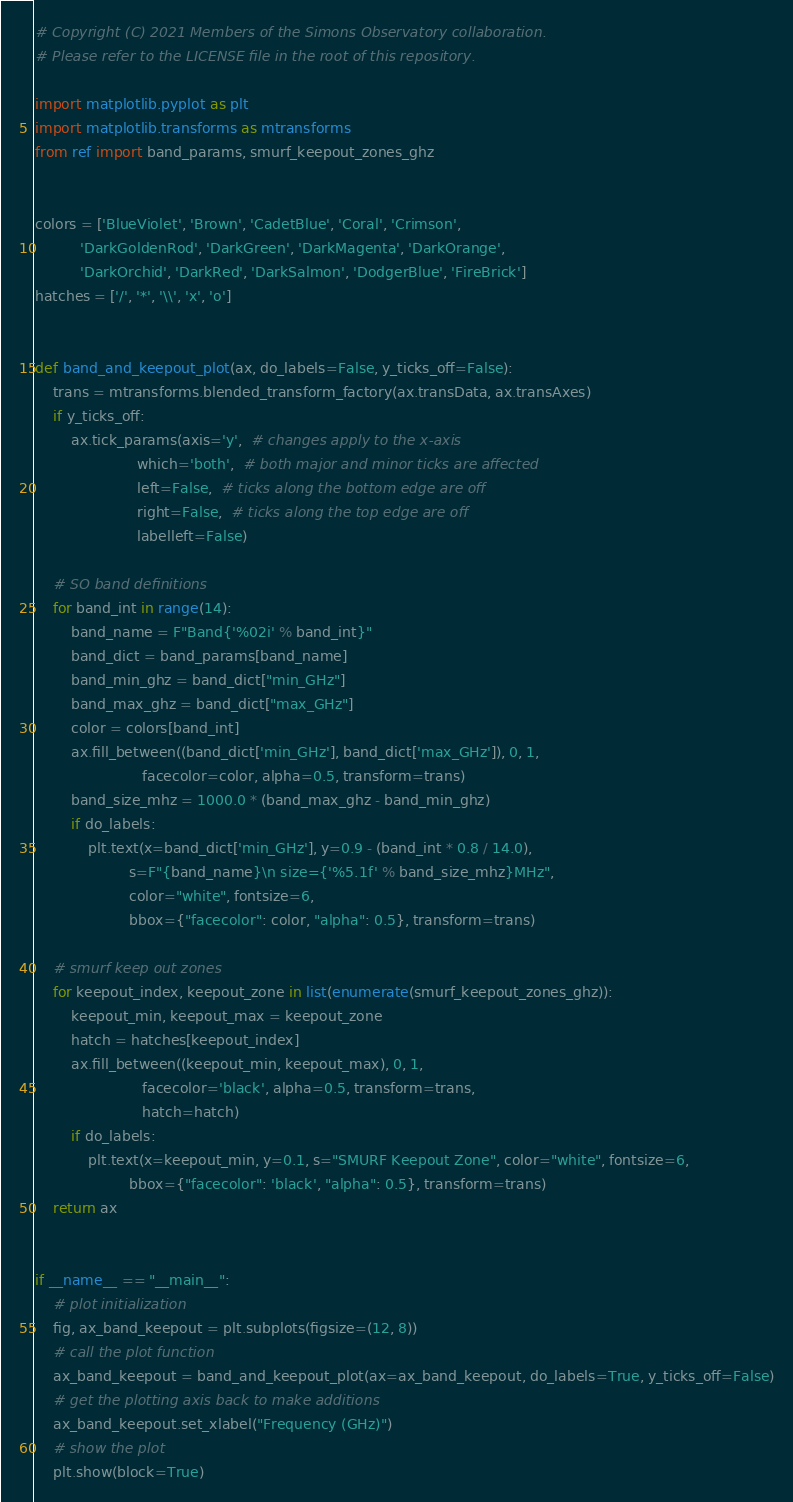<code> <loc_0><loc_0><loc_500><loc_500><_Python_># Copyright (C) 2021 Members of the Simons Observatory collaboration.
# Please refer to the LICENSE file in the root of this repository.

import matplotlib.pyplot as plt
import matplotlib.transforms as mtransforms
from ref import band_params, smurf_keepout_zones_ghz


colors = ['BlueViolet', 'Brown', 'CadetBlue', 'Coral', 'Crimson',
          'DarkGoldenRod', 'DarkGreen', 'DarkMagenta', 'DarkOrange',
          'DarkOrchid', 'DarkRed', 'DarkSalmon', 'DodgerBlue', 'FireBrick']
hatches = ['/', '*', '\\', 'x', 'o']


def band_and_keepout_plot(ax, do_labels=False, y_ticks_off=False):
    trans = mtransforms.blended_transform_factory(ax.transData, ax.transAxes)
    if y_ticks_off:
        ax.tick_params(axis='y',  # changes apply to the x-axis
                       which='both',  # both major and minor ticks are affected
                       left=False,  # ticks along the bottom edge are off
                       right=False,  # ticks along the top edge are off
                       labelleft=False)

    # SO band definitions
    for band_int in range(14):
        band_name = F"Band{'%02i' % band_int}"
        band_dict = band_params[band_name]
        band_min_ghz = band_dict["min_GHz"]
        band_max_ghz = band_dict["max_GHz"]
        color = colors[band_int]
        ax.fill_between((band_dict['min_GHz'], band_dict['max_GHz']), 0, 1,
                        facecolor=color, alpha=0.5, transform=trans)
        band_size_mhz = 1000.0 * (band_max_ghz - band_min_ghz)
        if do_labels:
            plt.text(x=band_dict['min_GHz'], y=0.9 - (band_int * 0.8 / 14.0),
                     s=F"{band_name}\n size={'%5.1f' % band_size_mhz}MHz",
                     color="white", fontsize=6,
                     bbox={"facecolor": color, "alpha": 0.5}, transform=trans)

    # smurf keep out zones
    for keepout_index, keepout_zone in list(enumerate(smurf_keepout_zones_ghz)):
        keepout_min, keepout_max = keepout_zone
        hatch = hatches[keepout_index]
        ax.fill_between((keepout_min, keepout_max), 0, 1,
                        facecolor='black', alpha=0.5, transform=trans,
                        hatch=hatch)
        if do_labels:
            plt.text(x=keepout_min, y=0.1, s="SMURF Keepout Zone", color="white", fontsize=6,
                     bbox={"facecolor": 'black', "alpha": 0.5}, transform=trans)
    return ax


if __name__ == "__main__":
    # plot initialization
    fig, ax_band_keepout = plt.subplots(figsize=(12, 8))
    # call the plot function
    ax_band_keepout = band_and_keepout_plot(ax=ax_band_keepout, do_labels=True, y_ticks_off=False)
    # get the plotting axis back to make additions
    ax_band_keepout.set_xlabel("Frequency (GHz)")
    # show the plot
    plt.show(block=True)
</code> 